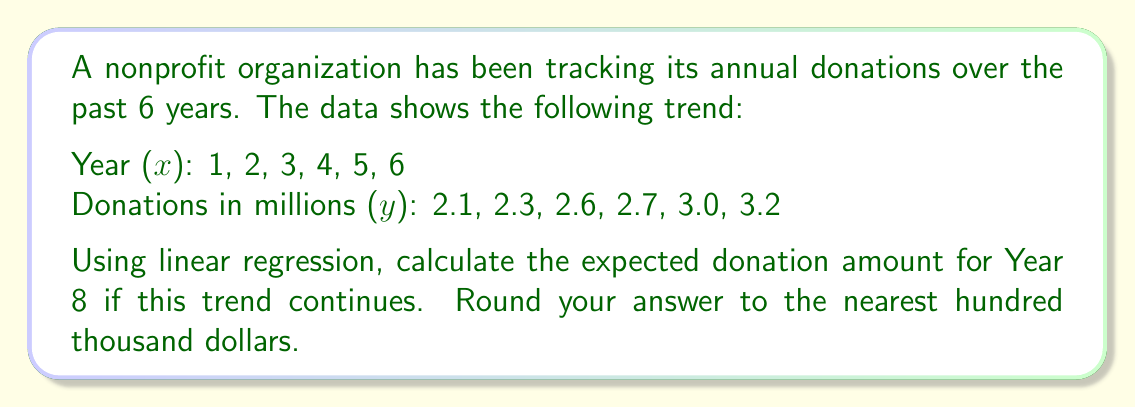Can you solve this math problem? To solve this problem, we'll use the linear regression formula:

$y = mx + b$

Where $m$ is the slope and $b$ is the y-intercept.

Step 1: Calculate the slope $m$
$m = \frac{n\sum xy - \sum x \sum y}{n\sum x^2 - (\sum x)^2}$

$n = 6$
$\sum x = 1 + 2 + 3 + 4 + 5 + 6 = 21$
$\sum y = 2.1 + 2.3 + 2.6 + 2.7 + 3.0 + 3.2 = 15.9$
$\sum xy = (1)(2.1) + (2)(2.3) + (3)(2.6) + (4)(2.7) + (5)(3.0) + (6)(3.2) = 62.5$
$\sum x^2 = 1^2 + 2^2 + 3^2 + 4^2 + 5^2 + 6^2 = 91$

$m = \frac{6(62.5) - 21(15.9)}{6(91) - 21^2} = \frac{375 - 333.9}{546 - 441} = \frac{41.1}{105} = 0.3914$

Step 2: Calculate the y-intercept $b$
$b = \frac{\sum y - m\sum x}{n} = \frac{15.9 - 0.3914(21)}{6} = 1.8705$

Step 3: Form the linear regression equation
$y = 0.3914x + 1.8705$

Step 4: Calculate the expected donation for Year 8
$y = 0.3914(8) + 1.8705 = 5.0017$

Step 5: Round to the nearest hundred thousand dollars
$5.0017$ million rounds to $5.0$ million
Answer: $5.0 million 